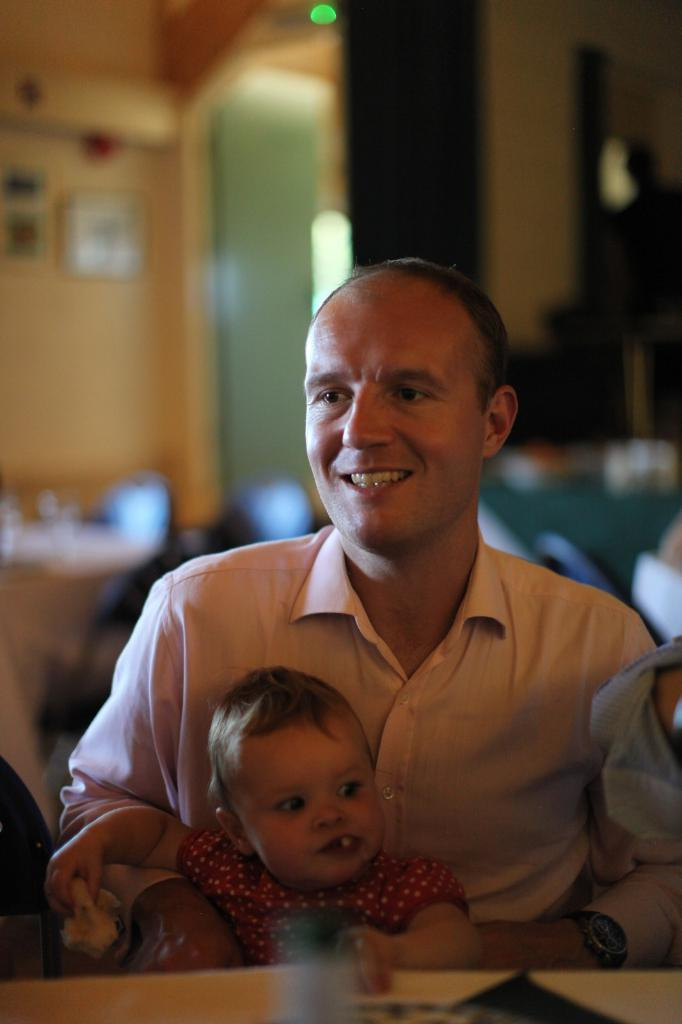What is the main subject of the image? There is a person in the image. What is the person wearing? The person is wearing a shirt. What is the person doing in the image? The person is carrying a child. Where is the person sitting in the image? The person is sitting near a table. Can you describe the background of the image? The background of the image is blurred. What type of rock is the person using to build a structure in the image? There is no rock present in the image, nor is the person building a structure. --- Facts: 1. There is a car in the image. 2. The car is parked on the street. 3. There are trees on the side of the street. 4. The sky is visible in the image. 5. The car has a red color. Absurd Topics: parrot, sand, bicycle Conversation: What is the main subject of the image? There is a car in the image. Where is the car located in the image? The car is parked on the street. What can be seen on the side of the street in the image? There are trees on the side of the street. What is visible in the background of the image? The sky is visible in the image. What color is the car in the image? The car has a red color. Reasoning: Let's think step by step in order to produce the conversation. We start by identifying the main subject of the image, which is the car. Then, we describe the car's location, the surrounding environment, and the background of the image. Finally, we mention the color of the car. Each question is designed to elicit a specific detail about the image that is known from the provided facts. Absurd Question/Answer: Can you tell me how many parrots are sitting on the car in the image? There are no parrots present in the image; it only features a red car parked on the street with trees on the side and a visible sky. 